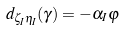<formula> <loc_0><loc_0><loc_500><loc_500>d _ { \zeta _ { I } \eta _ { I } } ( \gamma ) = - \alpha _ { I } \varphi</formula> 